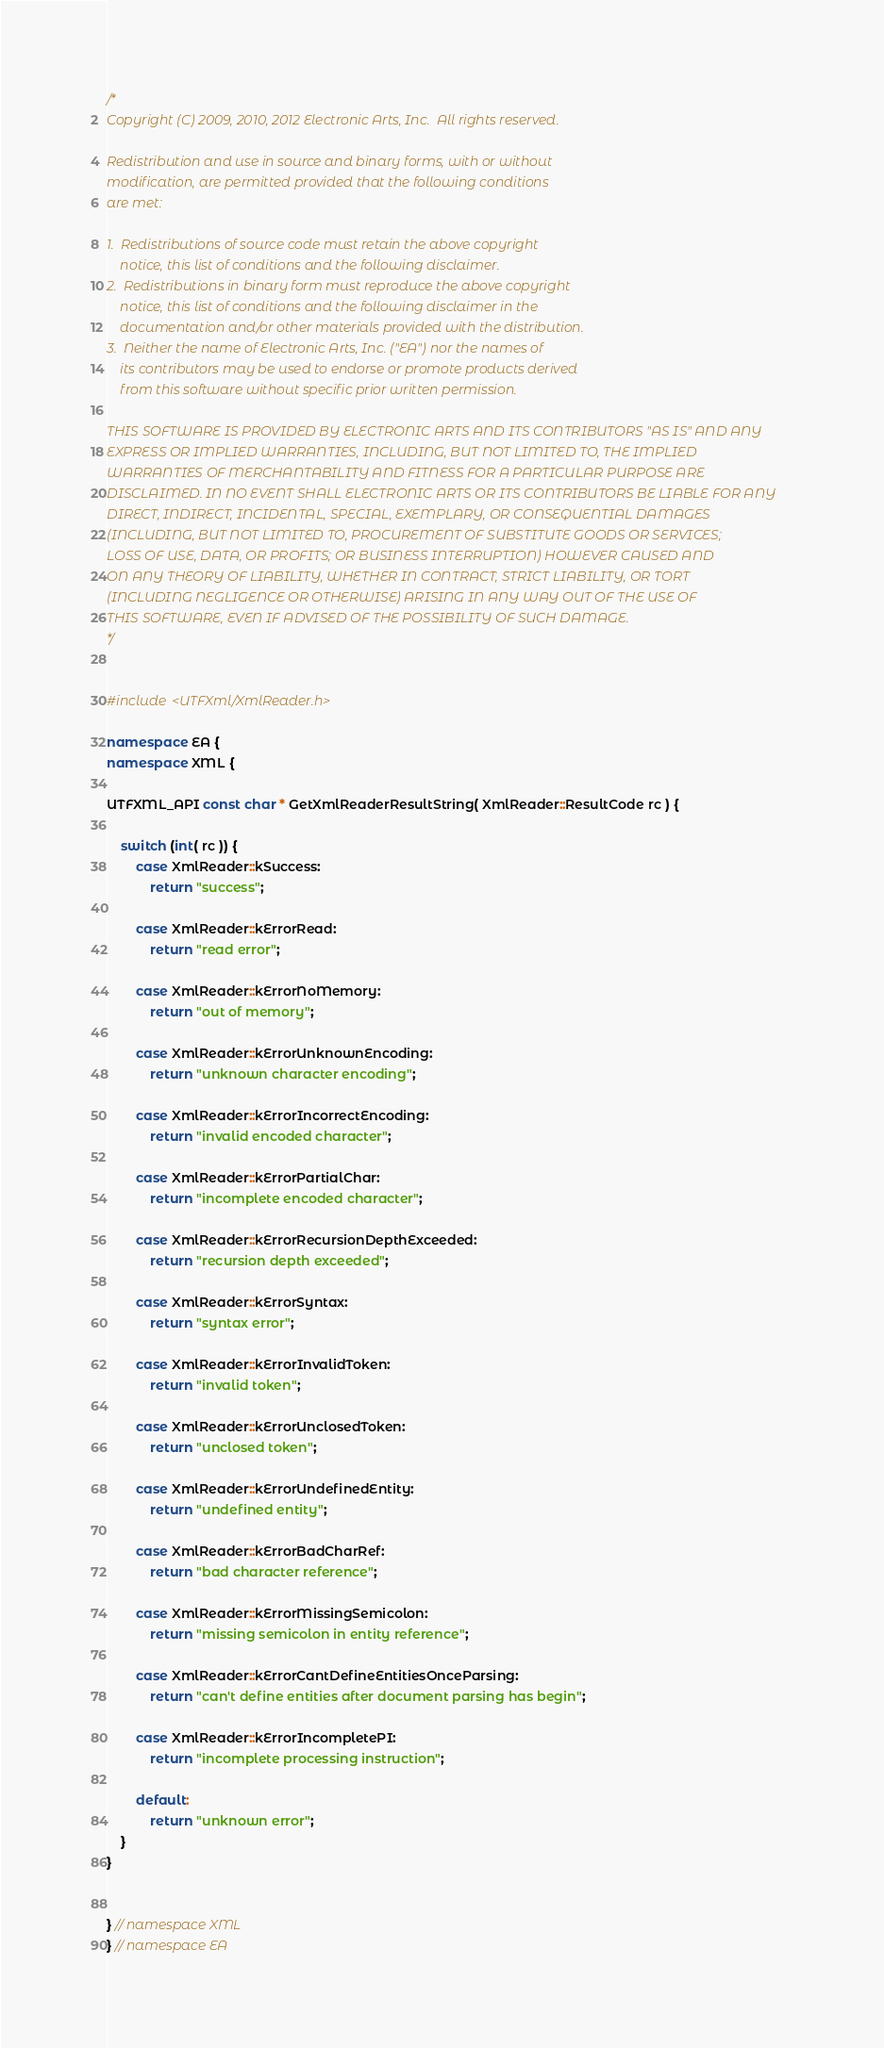Convert code to text. <code><loc_0><loc_0><loc_500><loc_500><_C++_>/*
Copyright (C) 2009, 2010, 2012 Electronic Arts, Inc.  All rights reserved.

Redistribution and use in source and binary forms, with or without
modification, are permitted provided that the following conditions
are met:

1.  Redistributions of source code must retain the above copyright
    notice, this list of conditions and the following disclaimer.
2.  Redistributions in binary form must reproduce the above copyright
    notice, this list of conditions and the following disclaimer in the
    documentation and/or other materials provided with the distribution.
3.  Neither the name of Electronic Arts, Inc. ("EA") nor the names of
    its contributors may be used to endorse or promote products derived
    from this software without specific prior written permission.

THIS SOFTWARE IS PROVIDED BY ELECTRONIC ARTS AND ITS CONTRIBUTORS "AS IS" AND ANY
EXPRESS OR IMPLIED WARRANTIES, INCLUDING, BUT NOT LIMITED TO, THE IMPLIED
WARRANTIES OF MERCHANTABILITY AND FITNESS FOR A PARTICULAR PURPOSE ARE
DISCLAIMED. IN NO EVENT SHALL ELECTRONIC ARTS OR ITS CONTRIBUTORS BE LIABLE FOR ANY
DIRECT, INDIRECT, INCIDENTAL, SPECIAL, EXEMPLARY, OR CONSEQUENTIAL DAMAGES
(INCLUDING, BUT NOT LIMITED TO, PROCUREMENT OF SUBSTITUTE GOODS OR SERVICES;
LOSS OF USE, DATA, OR PROFITS; OR BUSINESS INTERRUPTION) HOWEVER CAUSED AND
ON ANY THEORY OF LIABILITY, WHETHER IN CONTRACT, STRICT LIABILITY, OR TORT
(INCLUDING NEGLIGENCE OR OTHERWISE) ARISING IN ANY WAY OUT OF THE USE OF
THIS SOFTWARE, EVEN IF ADVISED OF THE POSSIBILITY OF SUCH DAMAGE.
*/


#include <UTFXml/XmlReader.h>

namespace EA {
namespace XML {

UTFXML_API const char * GetXmlReaderResultString( XmlReader::ResultCode rc ) {

    switch (int( rc )) {
        case XmlReader::kSuccess:
            return "success";

        case XmlReader::kErrorRead:
            return "read error";

        case XmlReader::kErrorNoMemory:
            return "out of memory";

        case XmlReader::kErrorUnknownEncoding:
            return "unknown character encoding";

        case XmlReader::kErrorIncorrectEncoding:
            return "invalid encoded character";

        case XmlReader::kErrorPartialChar:
            return "incomplete encoded character";

        case XmlReader::kErrorRecursionDepthExceeded:
            return "recursion depth exceeded";

        case XmlReader::kErrorSyntax:
            return "syntax error";

        case XmlReader::kErrorInvalidToken:
            return "invalid token";

        case XmlReader::kErrorUnclosedToken:
            return "unclosed token";

        case XmlReader::kErrorUndefinedEntity:
            return "undefined entity";

        case XmlReader::kErrorBadCharRef:
            return "bad character reference";

        case XmlReader::kErrorMissingSemicolon:
            return "missing semicolon in entity reference";

        case XmlReader::kErrorCantDefineEntitiesOnceParsing:
            return "can't define entities after document parsing has begin";

        case XmlReader::kErrorIncompletePI:
            return "incomplete processing instruction";

        default:
            return "unknown error";
    }
}


} // namespace XML
} // namespace EA






</code> 